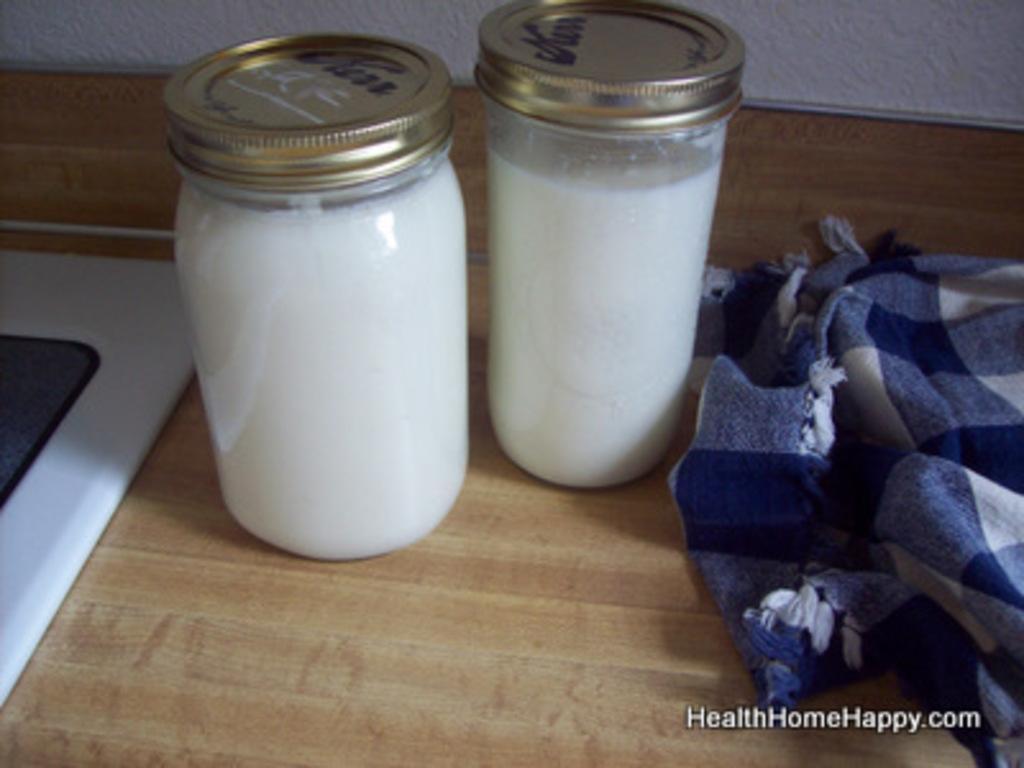How would you summarize this image in a sentence or two? In this picture we can see couple of bottles with drink in it, beside to the bottles we can find a cloth. 